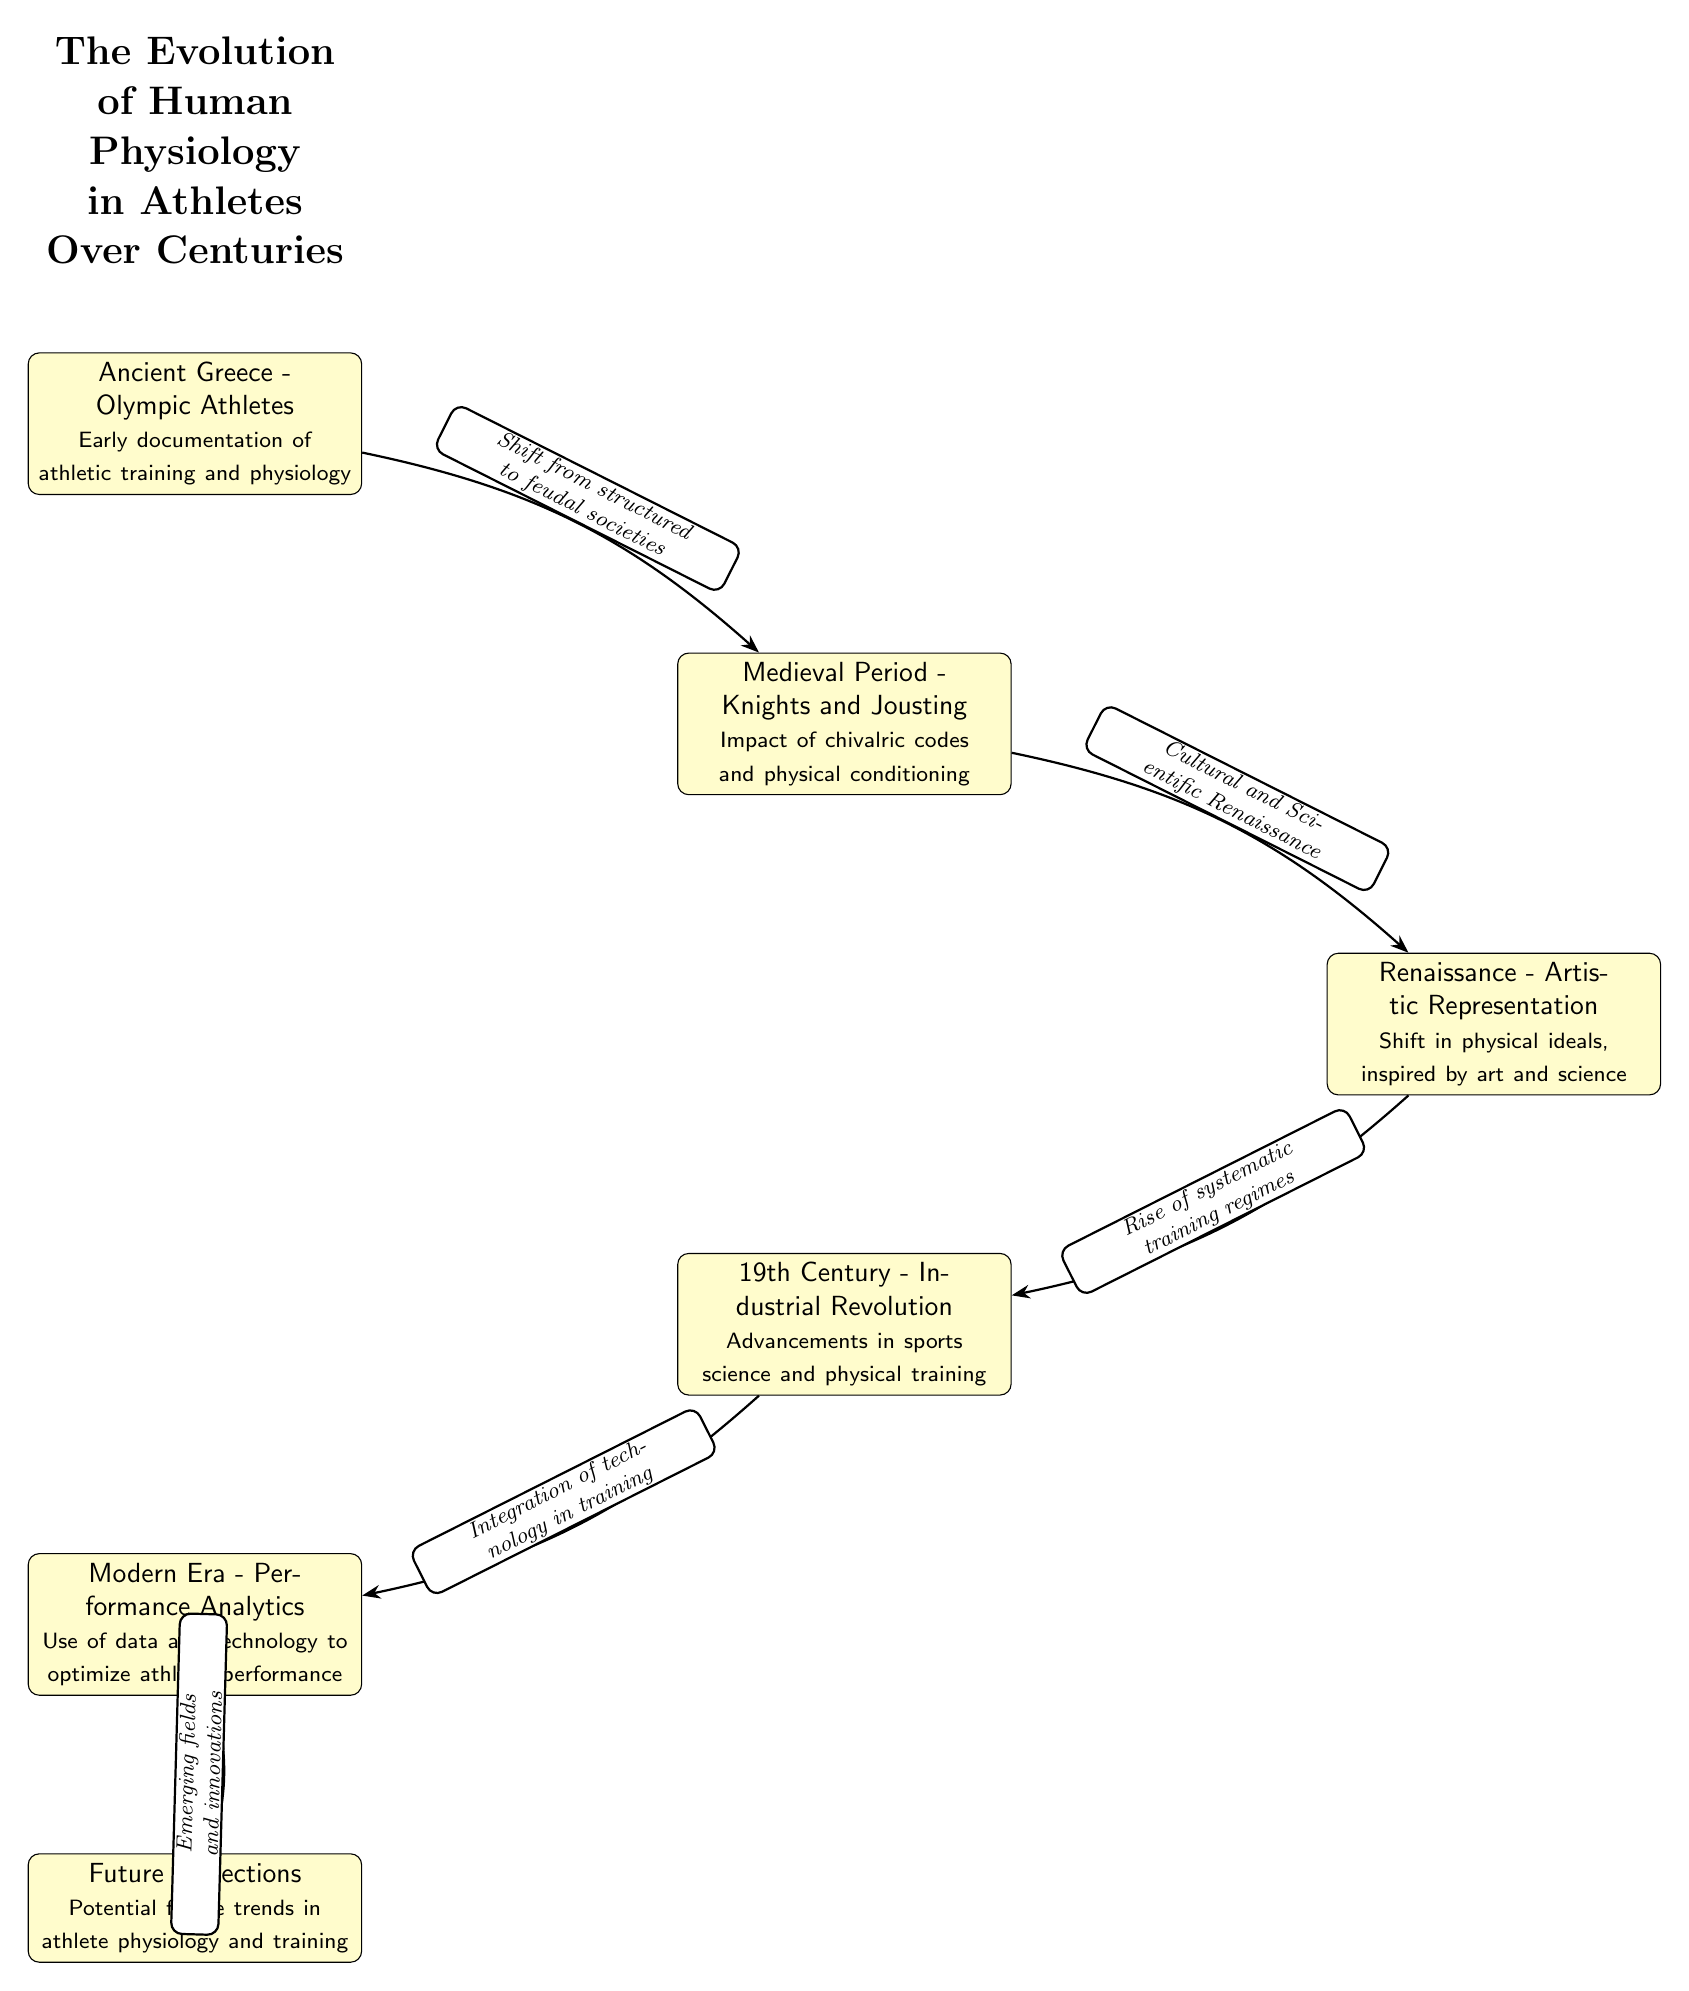What is the first node in the diagram? The first node depicts "Ancient Greece - Olympic Athletes," which is identified as the starting point in the evolutionary timeline of human physiology in athletes.
Answer: Ancient Greece - Olympic Athletes How many nodes are there in total? The diagram contains six nodes, each representing a different period in the evolution of human physiology in athletes, from Ancient Greece to Future Projections.
Answer: 6 What transition does the edge from the first to the second node indicate? The edge from the first node to the second node indicates the "Shift from structured to feudal societies," showing how societal structure influenced the evolution of athletic training.
Answer: Shift from structured to feudal societies What key aspect is highlighted in the fourth node? The fourth node focuses on the "19th Century - Industrial Revolution," highlighting the advancements in sports science and physical training during this era.
Answer: Advancements in sports science and physical training Which node directly follows the "Renaissance - Artistic Representation" node? The node that directly follows the "Renaissance - Artistic Representation" node is the "19th Century - Industrial Revolution" node, indicating the progression from the influence of art to scientific advancements.
Answer: 19th Century - Industrial Revolution What does the last node project about the future? The last node labeled "Future Projections" discusses potential future trends in athlete physiology and training, indicating ongoing evolution in these areas.
Answer: Potential future trends in athlete physiology and training How does the integration of technology relate to athlete performance? The edge from the "19th Century - Industrial Revolution" to the "Modern Era - Performance Analytics" node describes this relationship as the "Integration of technology in training," signifying a pivotal development in optimizing athletic performance.
Answer: Integration of technology in training Which node shows the impact of chivalric codes? The node "Medieval Period - Knights and Jousting" reflects the influence of chivalric codes on physical conditioning for athletes during this time.
Answer: Medieval Period - Knights and Jousting 